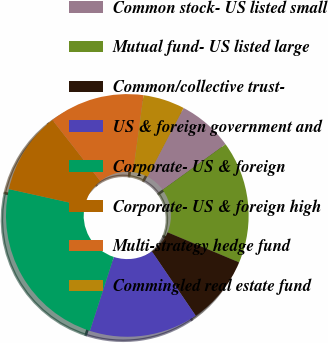Convert chart to OTSL. <chart><loc_0><loc_0><loc_500><loc_500><pie_chart><fcel>Common stock- US listed small<fcel>Mutual fund- US listed large<fcel>Common/collective trust-<fcel>US & foreign government and<fcel>Corporate- US & foreign<fcel>Corporate- US & foreign high<fcel>Multi-strategy hedge fund<fcel>Commingled real estate fund<nl><fcel>7.34%<fcel>16.31%<fcel>9.14%<fcel>14.52%<fcel>23.49%<fcel>10.93%<fcel>12.72%<fcel>5.55%<nl></chart> 